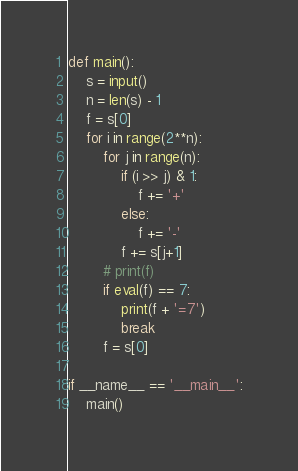Convert code to text. <code><loc_0><loc_0><loc_500><loc_500><_Python_>def main():
    s = input()
    n = len(s) - 1
    f = s[0]
    for i in range(2**n):
        for j in range(n):
            if (i >> j) & 1:
                f += '+'
            else:
                f += '-'
            f += s[j+1]
        # print(f)
        if eval(f) == 7:
            print(f + '=7')
            break
        f = s[0]

if __name__ == '__main__':
    main()</code> 